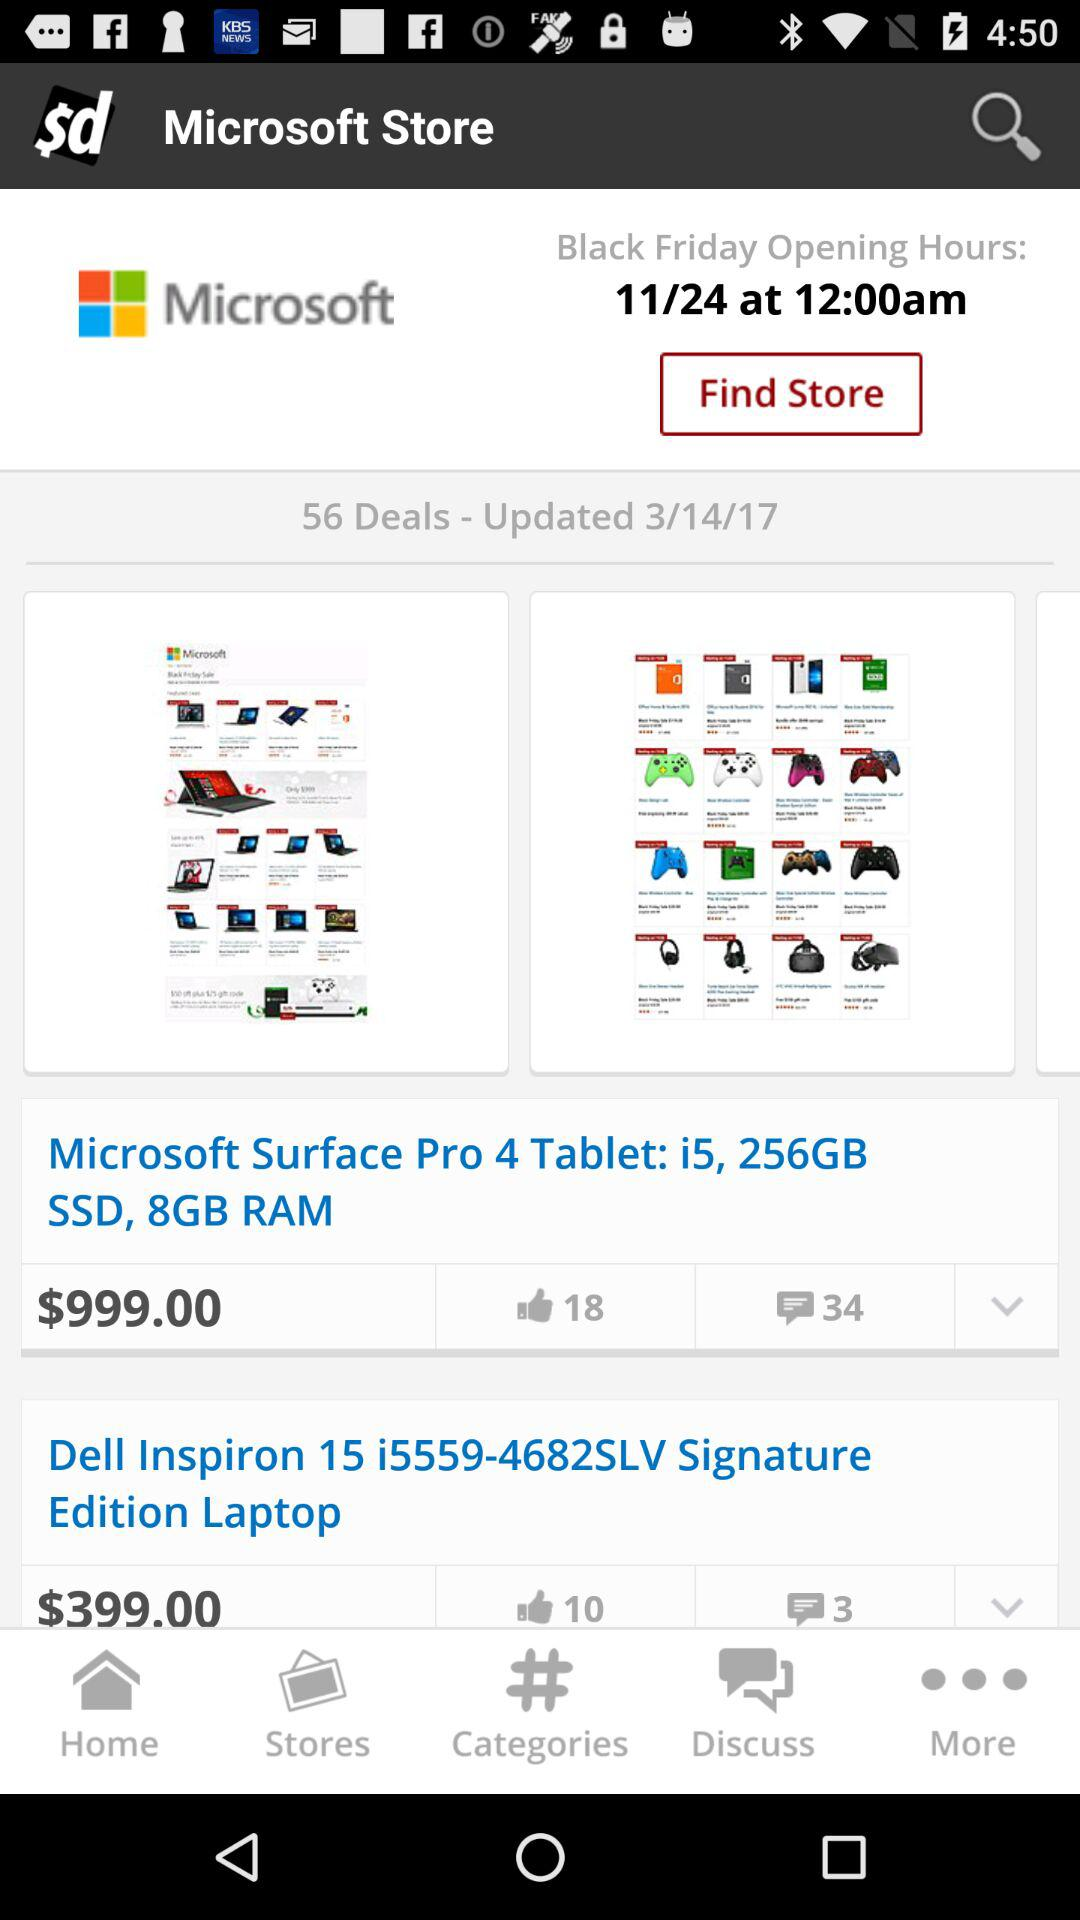Which day's opening hours are mentioned? The opening hours are mentioned for "Black Friday". 